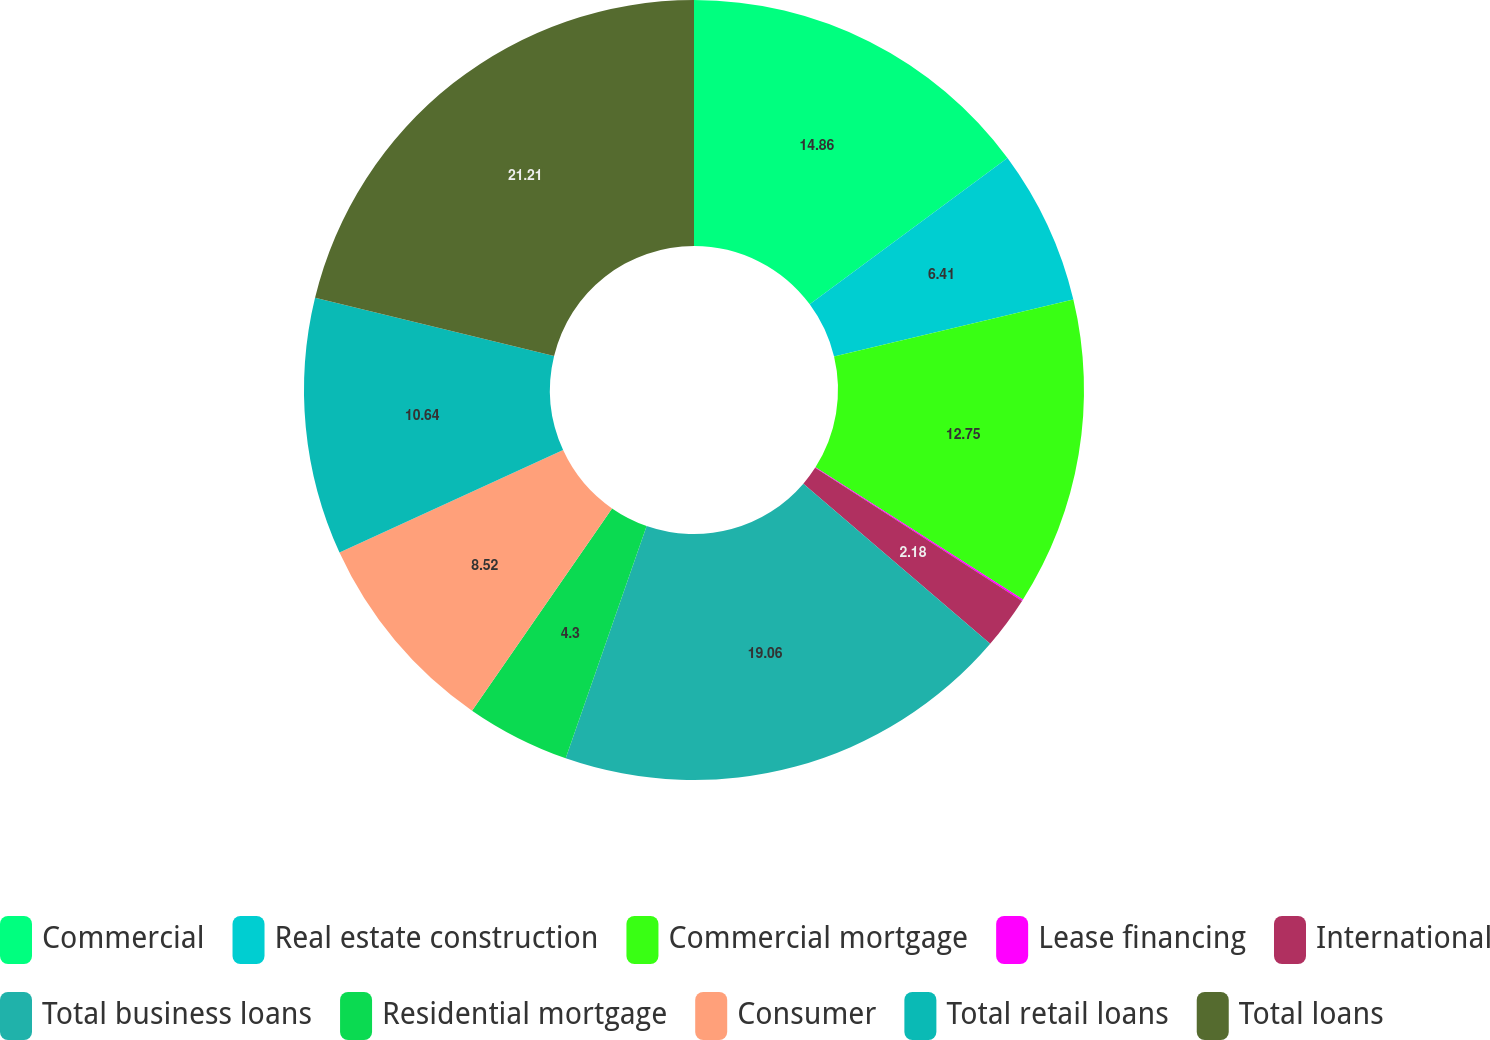Convert chart to OTSL. <chart><loc_0><loc_0><loc_500><loc_500><pie_chart><fcel>Commercial<fcel>Real estate construction<fcel>Commercial mortgage<fcel>Lease financing<fcel>International<fcel>Total business loans<fcel>Residential mortgage<fcel>Consumer<fcel>Total retail loans<fcel>Total loans<nl><fcel>14.86%<fcel>6.41%<fcel>12.75%<fcel>0.07%<fcel>2.18%<fcel>19.06%<fcel>4.3%<fcel>8.52%<fcel>10.64%<fcel>21.2%<nl></chart> 